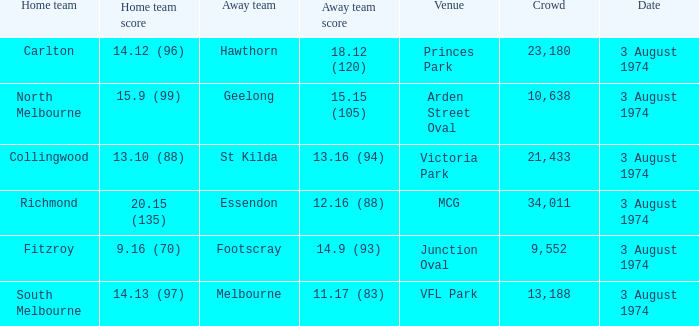Which Home team has a Venue of arden street oval? North Melbourne. 